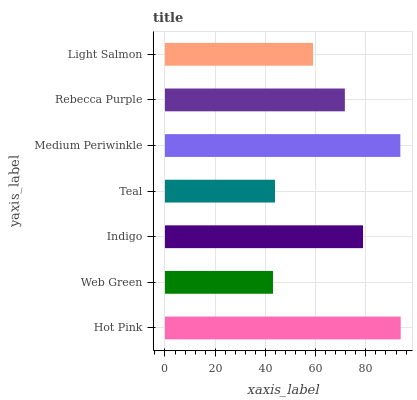Is Web Green the minimum?
Answer yes or no. Yes. Is Hot Pink the maximum?
Answer yes or no. Yes. Is Indigo the minimum?
Answer yes or no. No. Is Indigo the maximum?
Answer yes or no. No. Is Indigo greater than Web Green?
Answer yes or no. Yes. Is Web Green less than Indigo?
Answer yes or no. Yes. Is Web Green greater than Indigo?
Answer yes or no. No. Is Indigo less than Web Green?
Answer yes or no. No. Is Rebecca Purple the high median?
Answer yes or no. Yes. Is Rebecca Purple the low median?
Answer yes or no. Yes. Is Indigo the high median?
Answer yes or no. No. Is Medium Periwinkle the low median?
Answer yes or no. No. 